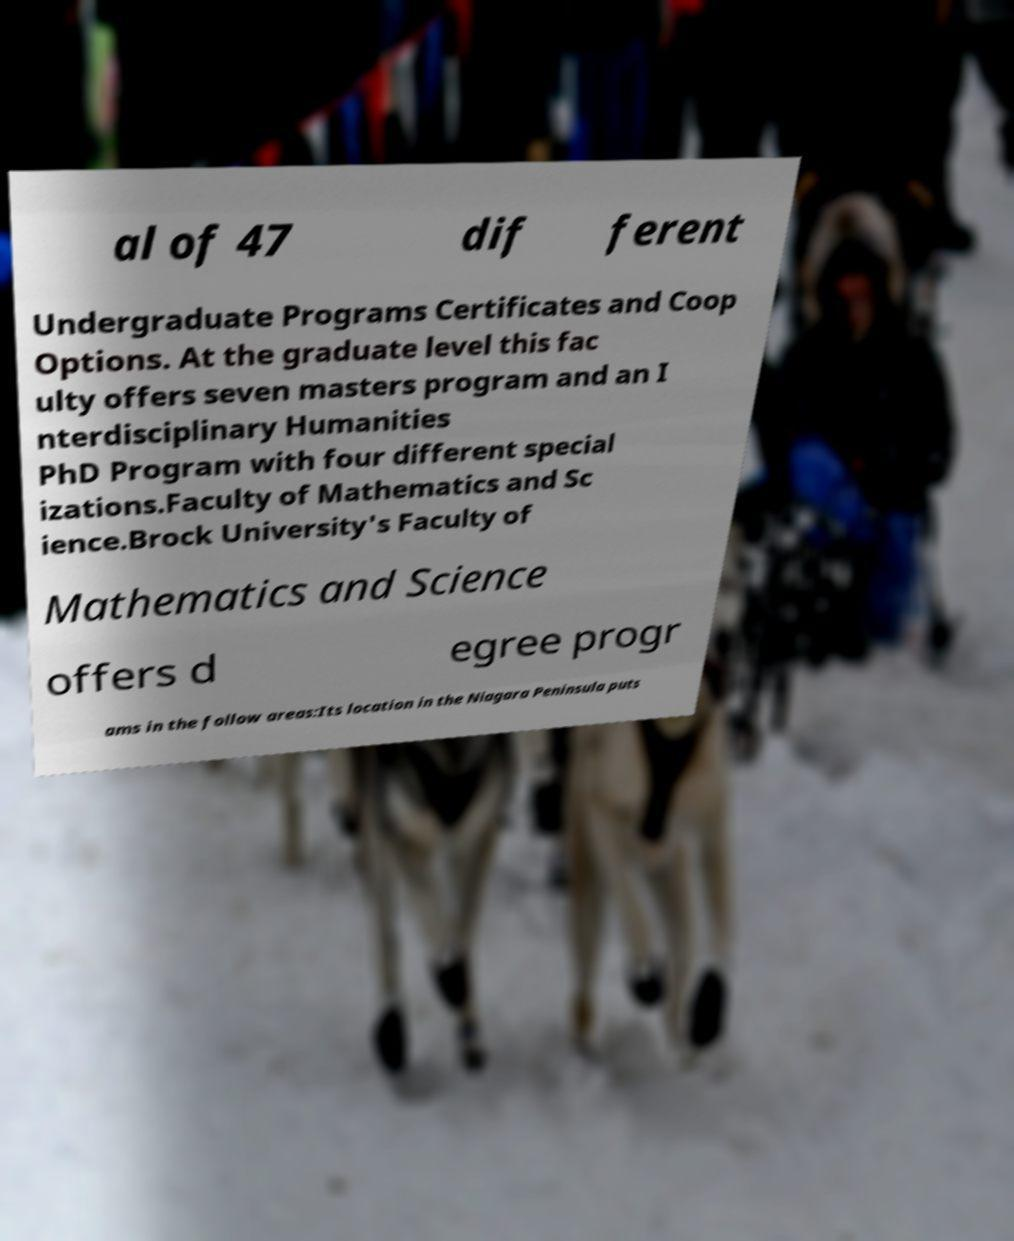For documentation purposes, I need the text within this image transcribed. Could you provide that? al of 47 dif ferent Undergraduate Programs Certificates and Coop Options. At the graduate level this fac ulty offers seven masters program and an I nterdisciplinary Humanities PhD Program with four different special izations.Faculty of Mathematics and Sc ience.Brock University's Faculty of Mathematics and Science offers d egree progr ams in the follow areas:Its location in the Niagara Peninsula puts 